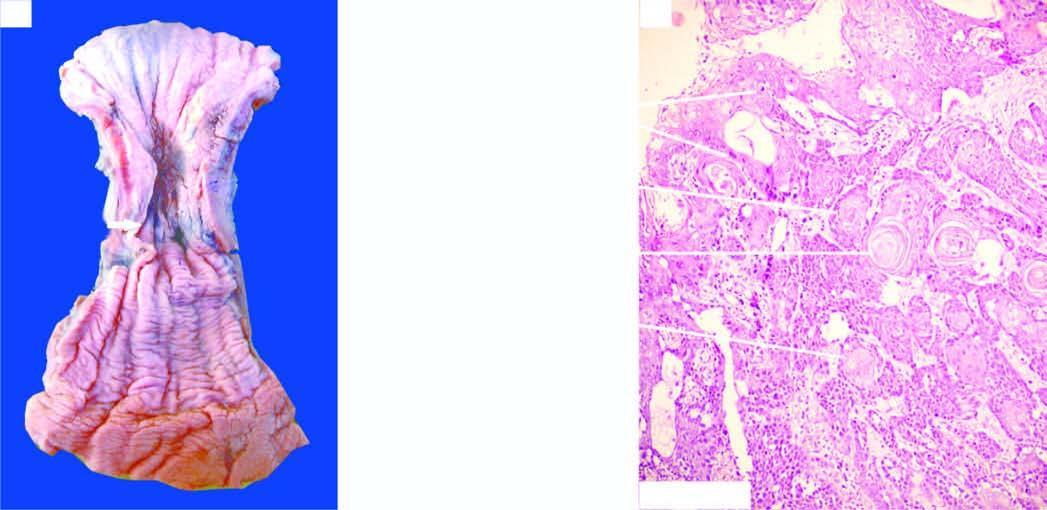s the vesselwall ulcerated?
Answer the question using a single word or phrase. No 